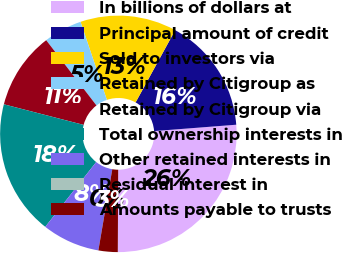<chart> <loc_0><loc_0><loc_500><loc_500><pie_chart><fcel>In billions of dollars at<fcel>Principal amount of credit<fcel>Sold to investors via<fcel>Retained by Citigroup as<fcel>Retained by Citigroup via<fcel>Total ownership interests in<fcel>Other retained interests in<fcel>Residual interest in<fcel>Amounts payable to trusts<nl><fcel>26.31%<fcel>15.79%<fcel>13.16%<fcel>5.27%<fcel>10.53%<fcel>18.42%<fcel>7.9%<fcel>0.0%<fcel>2.63%<nl></chart> 